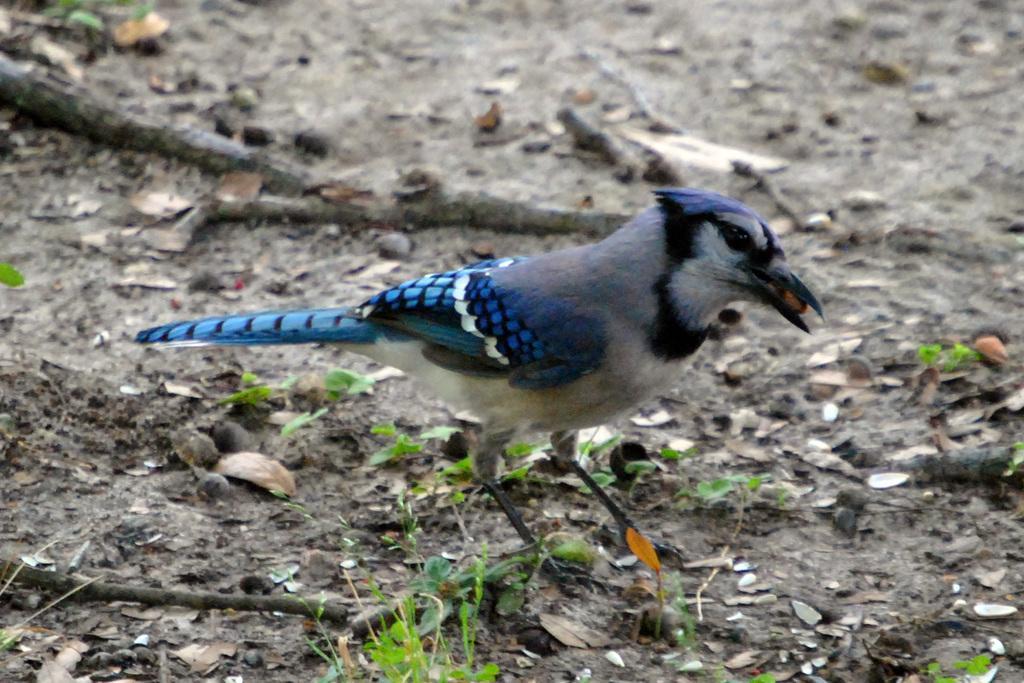Please provide a concise description of this image. In this picture we can see a bird, plants and sticks on the ground. 